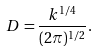Convert formula to latex. <formula><loc_0><loc_0><loc_500><loc_500>D = \frac { k ^ { 1 / 4 } } { ( 2 \pi ) ^ { 1 / 2 } } .</formula> 